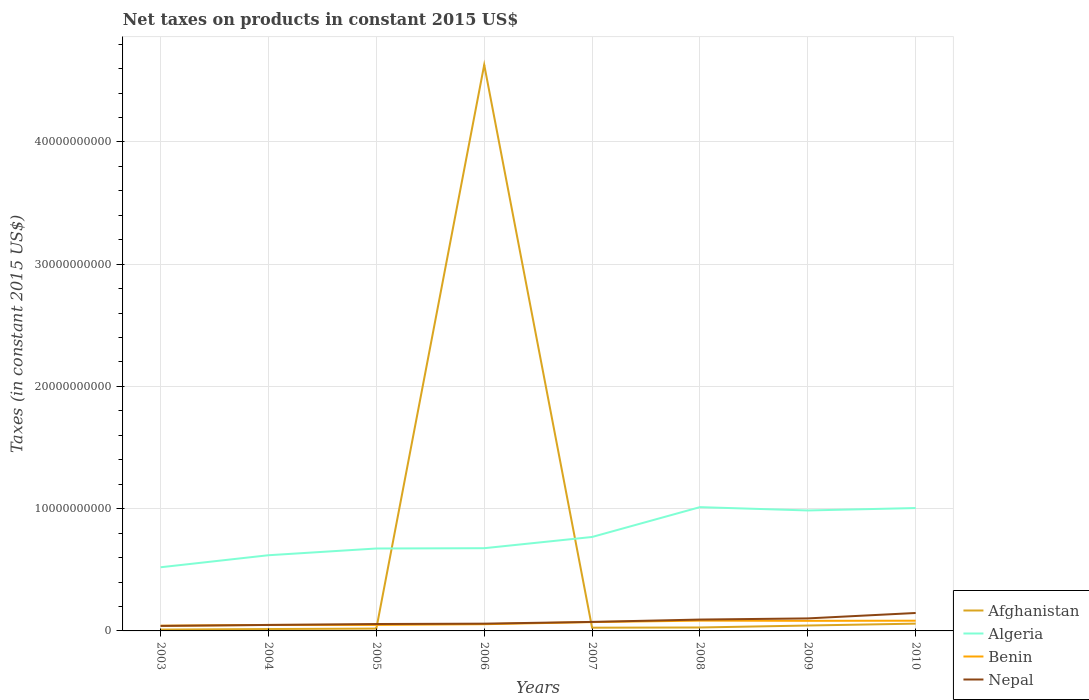Across all years, what is the maximum net taxes on products in Nepal?
Your answer should be very brief. 4.10e+08. In which year was the net taxes on products in Nepal maximum?
Provide a succinct answer. 2003. What is the total net taxes on products in Algeria in the graph?
Make the answer very short. -4.65e+09. What is the difference between the highest and the second highest net taxes on products in Algeria?
Make the answer very short. 4.92e+09. How many lines are there?
Your answer should be very brief. 4. What is the difference between two consecutive major ticks on the Y-axis?
Offer a very short reply. 1.00e+1. Where does the legend appear in the graph?
Keep it short and to the point. Bottom right. How are the legend labels stacked?
Make the answer very short. Vertical. What is the title of the graph?
Your response must be concise. Net taxes on products in constant 2015 US$. Does "Lesotho" appear as one of the legend labels in the graph?
Offer a very short reply. No. What is the label or title of the X-axis?
Offer a very short reply. Years. What is the label or title of the Y-axis?
Provide a succinct answer. Taxes (in constant 2015 US$). What is the Taxes (in constant 2015 US$) in Afghanistan in 2003?
Provide a succinct answer. 1.10e+08. What is the Taxes (in constant 2015 US$) in Algeria in 2003?
Keep it short and to the point. 5.21e+09. What is the Taxes (in constant 2015 US$) in Benin in 2003?
Your answer should be very brief. 4.25e+08. What is the Taxes (in constant 2015 US$) in Nepal in 2003?
Provide a succinct answer. 4.10e+08. What is the Taxes (in constant 2015 US$) in Afghanistan in 2004?
Your response must be concise. 1.54e+08. What is the Taxes (in constant 2015 US$) in Algeria in 2004?
Provide a short and direct response. 6.19e+09. What is the Taxes (in constant 2015 US$) in Benin in 2004?
Keep it short and to the point. 4.91e+08. What is the Taxes (in constant 2015 US$) of Nepal in 2004?
Provide a short and direct response. 4.89e+08. What is the Taxes (in constant 2015 US$) of Afghanistan in 2005?
Ensure brevity in your answer.  1.90e+08. What is the Taxes (in constant 2015 US$) in Algeria in 2005?
Provide a short and direct response. 6.74e+09. What is the Taxes (in constant 2015 US$) of Benin in 2005?
Provide a short and direct response. 4.91e+08. What is the Taxes (in constant 2015 US$) of Nepal in 2005?
Offer a very short reply. 5.65e+08. What is the Taxes (in constant 2015 US$) of Afghanistan in 2006?
Provide a succinct answer. 4.63e+1. What is the Taxes (in constant 2015 US$) of Algeria in 2006?
Your response must be concise. 6.77e+09. What is the Taxes (in constant 2015 US$) in Benin in 2006?
Ensure brevity in your answer.  5.49e+08. What is the Taxes (in constant 2015 US$) of Nepal in 2006?
Your response must be concise. 5.94e+08. What is the Taxes (in constant 2015 US$) of Afghanistan in 2007?
Make the answer very short. 2.65e+08. What is the Taxes (in constant 2015 US$) in Algeria in 2007?
Your answer should be very brief. 7.68e+09. What is the Taxes (in constant 2015 US$) of Benin in 2007?
Your response must be concise. 7.22e+08. What is the Taxes (in constant 2015 US$) of Nepal in 2007?
Offer a terse response. 7.37e+08. What is the Taxes (in constant 2015 US$) in Afghanistan in 2008?
Provide a succinct answer. 2.81e+08. What is the Taxes (in constant 2015 US$) in Algeria in 2008?
Your answer should be very brief. 1.01e+1. What is the Taxes (in constant 2015 US$) in Benin in 2008?
Your answer should be very brief. 8.43e+08. What is the Taxes (in constant 2015 US$) of Nepal in 2008?
Your response must be concise. 9.29e+08. What is the Taxes (in constant 2015 US$) of Afghanistan in 2009?
Ensure brevity in your answer.  4.42e+08. What is the Taxes (in constant 2015 US$) in Algeria in 2009?
Keep it short and to the point. 9.85e+09. What is the Taxes (in constant 2015 US$) in Benin in 2009?
Give a very brief answer. 8.26e+08. What is the Taxes (in constant 2015 US$) of Nepal in 2009?
Your response must be concise. 1.02e+09. What is the Taxes (in constant 2015 US$) of Afghanistan in 2010?
Give a very brief answer. 5.96e+08. What is the Taxes (in constant 2015 US$) of Algeria in 2010?
Your response must be concise. 1.01e+1. What is the Taxes (in constant 2015 US$) in Benin in 2010?
Provide a succinct answer. 8.35e+08. What is the Taxes (in constant 2015 US$) in Nepal in 2010?
Keep it short and to the point. 1.47e+09. Across all years, what is the maximum Taxes (in constant 2015 US$) in Afghanistan?
Provide a succinct answer. 4.63e+1. Across all years, what is the maximum Taxes (in constant 2015 US$) of Algeria?
Give a very brief answer. 1.01e+1. Across all years, what is the maximum Taxes (in constant 2015 US$) in Benin?
Make the answer very short. 8.43e+08. Across all years, what is the maximum Taxes (in constant 2015 US$) of Nepal?
Give a very brief answer. 1.47e+09. Across all years, what is the minimum Taxes (in constant 2015 US$) in Afghanistan?
Provide a succinct answer. 1.10e+08. Across all years, what is the minimum Taxes (in constant 2015 US$) in Algeria?
Your answer should be very brief. 5.21e+09. Across all years, what is the minimum Taxes (in constant 2015 US$) of Benin?
Provide a short and direct response. 4.25e+08. Across all years, what is the minimum Taxes (in constant 2015 US$) of Nepal?
Offer a terse response. 4.10e+08. What is the total Taxes (in constant 2015 US$) of Afghanistan in the graph?
Your answer should be very brief. 4.83e+1. What is the total Taxes (in constant 2015 US$) in Algeria in the graph?
Your response must be concise. 6.26e+1. What is the total Taxes (in constant 2015 US$) in Benin in the graph?
Give a very brief answer. 5.18e+09. What is the total Taxes (in constant 2015 US$) of Nepal in the graph?
Ensure brevity in your answer.  6.22e+09. What is the difference between the Taxes (in constant 2015 US$) of Afghanistan in 2003 and that in 2004?
Your answer should be very brief. -4.42e+07. What is the difference between the Taxes (in constant 2015 US$) of Algeria in 2003 and that in 2004?
Your answer should be compact. -9.83e+08. What is the difference between the Taxes (in constant 2015 US$) in Benin in 2003 and that in 2004?
Keep it short and to the point. -6.61e+07. What is the difference between the Taxes (in constant 2015 US$) of Nepal in 2003 and that in 2004?
Offer a terse response. -7.82e+07. What is the difference between the Taxes (in constant 2015 US$) in Afghanistan in 2003 and that in 2005?
Make the answer very short. -8.08e+07. What is the difference between the Taxes (in constant 2015 US$) of Algeria in 2003 and that in 2005?
Offer a terse response. -1.53e+09. What is the difference between the Taxes (in constant 2015 US$) of Benin in 2003 and that in 2005?
Ensure brevity in your answer.  -6.55e+07. What is the difference between the Taxes (in constant 2015 US$) in Nepal in 2003 and that in 2005?
Your answer should be very brief. -1.54e+08. What is the difference between the Taxes (in constant 2015 US$) in Afghanistan in 2003 and that in 2006?
Offer a terse response. -4.62e+1. What is the difference between the Taxes (in constant 2015 US$) in Algeria in 2003 and that in 2006?
Give a very brief answer. -1.56e+09. What is the difference between the Taxes (in constant 2015 US$) in Benin in 2003 and that in 2006?
Your response must be concise. -1.24e+08. What is the difference between the Taxes (in constant 2015 US$) in Nepal in 2003 and that in 2006?
Your answer should be compact. -1.84e+08. What is the difference between the Taxes (in constant 2015 US$) in Afghanistan in 2003 and that in 2007?
Give a very brief answer. -1.55e+08. What is the difference between the Taxes (in constant 2015 US$) of Algeria in 2003 and that in 2007?
Your response must be concise. -2.48e+09. What is the difference between the Taxes (in constant 2015 US$) in Benin in 2003 and that in 2007?
Provide a short and direct response. -2.97e+08. What is the difference between the Taxes (in constant 2015 US$) in Nepal in 2003 and that in 2007?
Make the answer very short. -3.27e+08. What is the difference between the Taxes (in constant 2015 US$) in Afghanistan in 2003 and that in 2008?
Offer a terse response. -1.72e+08. What is the difference between the Taxes (in constant 2015 US$) of Algeria in 2003 and that in 2008?
Your answer should be very brief. -4.92e+09. What is the difference between the Taxes (in constant 2015 US$) of Benin in 2003 and that in 2008?
Provide a succinct answer. -4.18e+08. What is the difference between the Taxes (in constant 2015 US$) of Nepal in 2003 and that in 2008?
Your answer should be compact. -5.19e+08. What is the difference between the Taxes (in constant 2015 US$) of Afghanistan in 2003 and that in 2009?
Make the answer very short. -3.33e+08. What is the difference between the Taxes (in constant 2015 US$) in Algeria in 2003 and that in 2009?
Give a very brief answer. -4.65e+09. What is the difference between the Taxes (in constant 2015 US$) in Benin in 2003 and that in 2009?
Keep it short and to the point. -4.01e+08. What is the difference between the Taxes (in constant 2015 US$) in Nepal in 2003 and that in 2009?
Your answer should be very brief. -6.14e+08. What is the difference between the Taxes (in constant 2015 US$) in Afghanistan in 2003 and that in 2010?
Provide a short and direct response. -4.87e+08. What is the difference between the Taxes (in constant 2015 US$) of Algeria in 2003 and that in 2010?
Keep it short and to the point. -4.84e+09. What is the difference between the Taxes (in constant 2015 US$) in Benin in 2003 and that in 2010?
Provide a short and direct response. -4.10e+08. What is the difference between the Taxes (in constant 2015 US$) in Nepal in 2003 and that in 2010?
Provide a short and direct response. -1.06e+09. What is the difference between the Taxes (in constant 2015 US$) of Afghanistan in 2004 and that in 2005?
Provide a short and direct response. -3.66e+07. What is the difference between the Taxes (in constant 2015 US$) of Algeria in 2004 and that in 2005?
Give a very brief answer. -5.51e+08. What is the difference between the Taxes (in constant 2015 US$) in Benin in 2004 and that in 2005?
Give a very brief answer. 5.67e+05. What is the difference between the Taxes (in constant 2015 US$) of Nepal in 2004 and that in 2005?
Keep it short and to the point. -7.60e+07. What is the difference between the Taxes (in constant 2015 US$) in Afghanistan in 2004 and that in 2006?
Your answer should be compact. -4.62e+1. What is the difference between the Taxes (in constant 2015 US$) in Algeria in 2004 and that in 2006?
Make the answer very short. -5.75e+08. What is the difference between the Taxes (in constant 2015 US$) of Benin in 2004 and that in 2006?
Give a very brief answer. -5.82e+07. What is the difference between the Taxes (in constant 2015 US$) in Nepal in 2004 and that in 2006?
Ensure brevity in your answer.  -1.06e+08. What is the difference between the Taxes (in constant 2015 US$) in Afghanistan in 2004 and that in 2007?
Keep it short and to the point. -1.11e+08. What is the difference between the Taxes (in constant 2015 US$) of Algeria in 2004 and that in 2007?
Your response must be concise. -1.49e+09. What is the difference between the Taxes (in constant 2015 US$) of Benin in 2004 and that in 2007?
Your answer should be compact. -2.31e+08. What is the difference between the Taxes (in constant 2015 US$) in Nepal in 2004 and that in 2007?
Make the answer very short. -2.49e+08. What is the difference between the Taxes (in constant 2015 US$) in Afghanistan in 2004 and that in 2008?
Your answer should be compact. -1.28e+08. What is the difference between the Taxes (in constant 2015 US$) of Algeria in 2004 and that in 2008?
Your answer should be compact. -3.93e+09. What is the difference between the Taxes (in constant 2015 US$) of Benin in 2004 and that in 2008?
Your answer should be compact. -3.52e+08. What is the difference between the Taxes (in constant 2015 US$) in Nepal in 2004 and that in 2008?
Provide a succinct answer. -4.40e+08. What is the difference between the Taxes (in constant 2015 US$) in Afghanistan in 2004 and that in 2009?
Give a very brief answer. -2.88e+08. What is the difference between the Taxes (in constant 2015 US$) of Algeria in 2004 and that in 2009?
Offer a very short reply. -3.66e+09. What is the difference between the Taxes (in constant 2015 US$) of Benin in 2004 and that in 2009?
Your response must be concise. -3.35e+08. What is the difference between the Taxes (in constant 2015 US$) of Nepal in 2004 and that in 2009?
Keep it short and to the point. -5.36e+08. What is the difference between the Taxes (in constant 2015 US$) in Afghanistan in 2004 and that in 2010?
Provide a short and direct response. -4.42e+08. What is the difference between the Taxes (in constant 2015 US$) in Algeria in 2004 and that in 2010?
Provide a succinct answer. -3.86e+09. What is the difference between the Taxes (in constant 2015 US$) in Benin in 2004 and that in 2010?
Offer a very short reply. -3.44e+08. What is the difference between the Taxes (in constant 2015 US$) in Nepal in 2004 and that in 2010?
Your answer should be very brief. -9.79e+08. What is the difference between the Taxes (in constant 2015 US$) in Afghanistan in 2005 and that in 2006?
Provide a short and direct response. -4.61e+1. What is the difference between the Taxes (in constant 2015 US$) of Algeria in 2005 and that in 2006?
Provide a short and direct response. -2.43e+07. What is the difference between the Taxes (in constant 2015 US$) in Benin in 2005 and that in 2006?
Provide a short and direct response. -5.88e+07. What is the difference between the Taxes (in constant 2015 US$) of Nepal in 2005 and that in 2006?
Your response must be concise. -2.95e+07. What is the difference between the Taxes (in constant 2015 US$) in Afghanistan in 2005 and that in 2007?
Make the answer very short. -7.45e+07. What is the difference between the Taxes (in constant 2015 US$) of Algeria in 2005 and that in 2007?
Offer a terse response. -9.42e+08. What is the difference between the Taxes (in constant 2015 US$) of Benin in 2005 and that in 2007?
Ensure brevity in your answer.  -2.31e+08. What is the difference between the Taxes (in constant 2015 US$) in Nepal in 2005 and that in 2007?
Your answer should be compact. -1.73e+08. What is the difference between the Taxes (in constant 2015 US$) of Afghanistan in 2005 and that in 2008?
Give a very brief answer. -9.09e+07. What is the difference between the Taxes (in constant 2015 US$) of Algeria in 2005 and that in 2008?
Your response must be concise. -3.38e+09. What is the difference between the Taxes (in constant 2015 US$) in Benin in 2005 and that in 2008?
Your answer should be very brief. -3.52e+08. What is the difference between the Taxes (in constant 2015 US$) in Nepal in 2005 and that in 2008?
Offer a terse response. -3.64e+08. What is the difference between the Taxes (in constant 2015 US$) of Afghanistan in 2005 and that in 2009?
Provide a succinct answer. -2.52e+08. What is the difference between the Taxes (in constant 2015 US$) in Algeria in 2005 and that in 2009?
Offer a very short reply. -3.11e+09. What is the difference between the Taxes (in constant 2015 US$) of Benin in 2005 and that in 2009?
Provide a succinct answer. -3.35e+08. What is the difference between the Taxes (in constant 2015 US$) of Nepal in 2005 and that in 2009?
Give a very brief answer. -4.60e+08. What is the difference between the Taxes (in constant 2015 US$) in Afghanistan in 2005 and that in 2010?
Offer a terse response. -4.06e+08. What is the difference between the Taxes (in constant 2015 US$) of Algeria in 2005 and that in 2010?
Give a very brief answer. -3.31e+09. What is the difference between the Taxes (in constant 2015 US$) in Benin in 2005 and that in 2010?
Provide a short and direct response. -3.45e+08. What is the difference between the Taxes (in constant 2015 US$) in Nepal in 2005 and that in 2010?
Your response must be concise. -9.03e+08. What is the difference between the Taxes (in constant 2015 US$) of Afghanistan in 2006 and that in 2007?
Give a very brief answer. 4.60e+1. What is the difference between the Taxes (in constant 2015 US$) in Algeria in 2006 and that in 2007?
Offer a very short reply. -9.18e+08. What is the difference between the Taxes (in constant 2015 US$) in Benin in 2006 and that in 2007?
Offer a very short reply. -1.73e+08. What is the difference between the Taxes (in constant 2015 US$) in Nepal in 2006 and that in 2007?
Offer a terse response. -1.43e+08. What is the difference between the Taxes (in constant 2015 US$) in Afghanistan in 2006 and that in 2008?
Offer a terse response. 4.60e+1. What is the difference between the Taxes (in constant 2015 US$) of Algeria in 2006 and that in 2008?
Keep it short and to the point. -3.36e+09. What is the difference between the Taxes (in constant 2015 US$) in Benin in 2006 and that in 2008?
Ensure brevity in your answer.  -2.93e+08. What is the difference between the Taxes (in constant 2015 US$) in Nepal in 2006 and that in 2008?
Keep it short and to the point. -3.35e+08. What is the difference between the Taxes (in constant 2015 US$) of Afghanistan in 2006 and that in 2009?
Offer a very short reply. 4.59e+1. What is the difference between the Taxes (in constant 2015 US$) in Algeria in 2006 and that in 2009?
Your response must be concise. -3.09e+09. What is the difference between the Taxes (in constant 2015 US$) of Benin in 2006 and that in 2009?
Give a very brief answer. -2.76e+08. What is the difference between the Taxes (in constant 2015 US$) of Nepal in 2006 and that in 2009?
Your answer should be very brief. -4.30e+08. What is the difference between the Taxes (in constant 2015 US$) in Afghanistan in 2006 and that in 2010?
Ensure brevity in your answer.  4.57e+1. What is the difference between the Taxes (in constant 2015 US$) in Algeria in 2006 and that in 2010?
Make the answer very short. -3.29e+09. What is the difference between the Taxes (in constant 2015 US$) of Benin in 2006 and that in 2010?
Give a very brief answer. -2.86e+08. What is the difference between the Taxes (in constant 2015 US$) in Nepal in 2006 and that in 2010?
Give a very brief answer. -8.73e+08. What is the difference between the Taxes (in constant 2015 US$) of Afghanistan in 2007 and that in 2008?
Give a very brief answer. -1.64e+07. What is the difference between the Taxes (in constant 2015 US$) of Algeria in 2007 and that in 2008?
Provide a succinct answer. -2.44e+09. What is the difference between the Taxes (in constant 2015 US$) of Benin in 2007 and that in 2008?
Provide a short and direct response. -1.21e+08. What is the difference between the Taxes (in constant 2015 US$) in Nepal in 2007 and that in 2008?
Make the answer very short. -1.92e+08. What is the difference between the Taxes (in constant 2015 US$) in Afghanistan in 2007 and that in 2009?
Your answer should be compact. -1.77e+08. What is the difference between the Taxes (in constant 2015 US$) of Algeria in 2007 and that in 2009?
Your answer should be compact. -2.17e+09. What is the difference between the Taxes (in constant 2015 US$) in Benin in 2007 and that in 2009?
Provide a short and direct response. -1.04e+08. What is the difference between the Taxes (in constant 2015 US$) of Nepal in 2007 and that in 2009?
Offer a very short reply. -2.87e+08. What is the difference between the Taxes (in constant 2015 US$) in Afghanistan in 2007 and that in 2010?
Ensure brevity in your answer.  -3.31e+08. What is the difference between the Taxes (in constant 2015 US$) of Algeria in 2007 and that in 2010?
Ensure brevity in your answer.  -2.37e+09. What is the difference between the Taxes (in constant 2015 US$) in Benin in 2007 and that in 2010?
Your response must be concise. -1.13e+08. What is the difference between the Taxes (in constant 2015 US$) in Nepal in 2007 and that in 2010?
Offer a terse response. -7.30e+08. What is the difference between the Taxes (in constant 2015 US$) of Afghanistan in 2008 and that in 2009?
Your answer should be very brief. -1.61e+08. What is the difference between the Taxes (in constant 2015 US$) in Algeria in 2008 and that in 2009?
Ensure brevity in your answer.  2.72e+08. What is the difference between the Taxes (in constant 2015 US$) of Benin in 2008 and that in 2009?
Ensure brevity in your answer.  1.70e+07. What is the difference between the Taxes (in constant 2015 US$) of Nepal in 2008 and that in 2009?
Offer a very short reply. -9.53e+07. What is the difference between the Taxes (in constant 2015 US$) in Afghanistan in 2008 and that in 2010?
Provide a short and direct response. -3.15e+08. What is the difference between the Taxes (in constant 2015 US$) in Algeria in 2008 and that in 2010?
Your answer should be compact. 7.40e+07. What is the difference between the Taxes (in constant 2015 US$) of Benin in 2008 and that in 2010?
Offer a very short reply. 7.49e+06. What is the difference between the Taxes (in constant 2015 US$) of Nepal in 2008 and that in 2010?
Give a very brief answer. -5.38e+08. What is the difference between the Taxes (in constant 2015 US$) of Afghanistan in 2009 and that in 2010?
Offer a very short reply. -1.54e+08. What is the difference between the Taxes (in constant 2015 US$) of Algeria in 2009 and that in 2010?
Offer a very short reply. -1.98e+08. What is the difference between the Taxes (in constant 2015 US$) of Benin in 2009 and that in 2010?
Offer a terse response. -9.56e+06. What is the difference between the Taxes (in constant 2015 US$) in Nepal in 2009 and that in 2010?
Your answer should be compact. -4.43e+08. What is the difference between the Taxes (in constant 2015 US$) of Afghanistan in 2003 and the Taxes (in constant 2015 US$) of Algeria in 2004?
Keep it short and to the point. -6.08e+09. What is the difference between the Taxes (in constant 2015 US$) in Afghanistan in 2003 and the Taxes (in constant 2015 US$) in Benin in 2004?
Make the answer very short. -3.82e+08. What is the difference between the Taxes (in constant 2015 US$) of Afghanistan in 2003 and the Taxes (in constant 2015 US$) of Nepal in 2004?
Provide a short and direct response. -3.79e+08. What is the difference between the Taxes (in constant 2015 US$) in Algeria in 2003 and the Taxes (in constant 2015 US$) in Benin in 2004?
Offer a very short reply. 4.72e+09. What is the difference between the Taxes (in constant 2015 US$) in Algeria in 2003 and the Taxes (in constant 2015 US$) in Nepal in 2004?
Give a very brief answer. 4.72e+09. What is the difference between the Taxes (in constant 2015 US$) of Benin in 2003 and the Taxes (in constant 2015 US$) of Nepal in 2004?
Offer a very short reply. -6.34e+07. What is the difference between the Taxes (in constant 2015 US$) in Afghanistan in 2003 and the Taxes (in constant 2015 US$) in Algeria in 2005?
Offer a terse response. -6.63e+09. What is the difference between the Taxes (in constant 2015 US$) of Afghanistan in 2003 and the Taxes (in constant 2015 US$) of Benin in 2005?
Offer a terse response. -3.81e+08. What is the difference between the Taxes (in constant 2015 US$) in Afghanistan in 2003 and the Taxes (in constant 2015 US$) in Nepal in 2005?
Keep it short and to the point. -4.55e+08. What is the difference between the Taxes (in constant 2015 US$) in Algeria in 2003 and the Taxes (in constant 2015 US$) in Benin in 2005?
Keep it short and to the point. 4.72e+09. What is the difference between the Taxes (in constant 2015 US$) in Algeria in 2003 and the Taxes (in constant 2015 US$) in Nepal in 2005?
Offer a terse response. 4.64e+09. What is the difference between the Taxes (in constant 2015 US$) in Benin in 2003 and the Taxes (in constant 2015 US$) in Nepal in 2005?
Keep it short and to the point. -1.39e+08. What is the difference between the Taxes (in constant 2015 US$) of Afghanistan in 2003 and the Taxes (in constant 2015 US$) of Algeria in 2006?
Your answer should be very brief. -6.66e+09. What is the difference between the Taxes (in constant 2015 US$) in Afghanistan in 2003 and the Taxes (in constant 2015 US$) in Benin in 2006?
Offer a very short reply. -4.40e+08. What is the difference between the Taxes (in constant 2015 US$) in Afghanistan in 2003 and the Taxes (in constant 2015 US$) in Nepal in 2006?
Offer a very short reply. -4.85e+08. What is the difference between the Taxes (in constant 2015 US$) in Algeria in 2003 and the Taxes (in constant 2015 US$) in Benin in 2006?
Keep it short and to the point. 4.66e+09. What is the difference between the Taxes (in constant 2015 US$) of Algeria in 2003 and the Taxes (in constant 2015 US$) of Nepal in 2006?
Your response must be concise. 4.61e+09. What is the difference between the Taxes (in constant 2015 US$) of Benin in 2003 and the Taxes (in constant 2015 US$) of Nepal in 2006?
Your answer should be compact. -1.69e+08. What is the difference between the Taxes (in constant 2015 US$) of Afghanistan in 2003 and the Taxes (in constant 2015 US$) of Algeria in 2007?
Offer a very short reply. -7.57e+09. What is the difference between the Taxes (in constant 2015 US$) in Afghanistan in 2003 and the Taxes (in constant 2015 US$) in Benin in 2007?
Ensure brevity in your answer.  -6.13e+08. What is the difference between the Taxes (in constant 2015 US$) of Afghanistan in 2003 and the Taxes (in constant 2015 US$) of Nepal in 2007?
Ensure brevity in your answer.  -6.28e+08. What is the difference between the Taxes (in constant 2015 US$) in Algeria in 2003 and the Taxes (in constant 2015 US$) in Benin in 2007?
Provide a succinct answer. 4.49e+09. What is the difference between the Taxes (in constant 2015 US$) in Algeria in 2003 and the Taxes (in constant 2015 US$) in Nepal in 2007?
Your answer should be compact. 4.47e+09. What is the difference between the Taxes (in constant 2015 US$) in Benin in 2003 and the Taxes (in constant 2015 US$) in Nepal in 2007?
Give a very brief answer. -3.12e+08. What is the difference between the Taxes (in constant 2015 US$) of Afghanistan in 2003 and the Taxes (in constant 2015 US$) of Algeria in 2008?
Offer a very short reply. -1.00e+1. What is the difference between the Taxes (in constant 2015 US$) in Afghanistan in 2003 and the Taxes (in constant 2015 US$) in Benin in 2008?
Offer a very short reply. -7.33e+08. What is the difference between the Taxes (in constant 2015 US$) in Afghanistan in 2003 and the Taxes (in constant 2015 US$) in Nepal in 2008?
Offer a very short reply. -8.19e+08. What is the difference between the Taxes (in constant 2015 US$) in Algeria in 2003 and the Taxes (in constant 2015 US$) in Benin in 2008?
Offer a terse response. 4.37e+09. What is the difference between the Taxes (in constant 2015 US$) of Algeria in 2003 and the Taxes (in constant 2015 US$) of Nepal in 2008?
Keep it short and to the point. 4.28e+09. What is the difference between the Taxes (in constant 2015 US$) in Benin in 2003 and the Taxes (in constant 2015 US$) in Nepal in 2008?
Provide a succinct answer. -5.04e+08. What is the difference between the Taxes (in constant 2015 US$) of Afghanistan in 2003 and the Taxes (in constant 2015 US$) of Algeria in 2009?
Ensure brevity in your answer.  -9.74e+09. What is the difference between the Taxes (in constant 2015 US$) in Afghanistan in 2003 and the Taxes (in constant 2015 US$) in Benin in 2009?
Provide a short and direct response. -7.16e+08. What is the difference between the Taxes (in constant 2015 US$) of Afghanistan in 2003 and the Taxes (in constant 2015 US$) of Nepal in 2009?
Your answer should be compact. -9.15e+08. What is the difference between the Taxes (in constant 2015 US$) of Algeria in 2003 and the Taxes (in constant 2015 US$) of Benin in 2009?
Your answer should be compact. 4.38e+09. What is the difference between the Taxes (in constant 2015 US$) of Algeria in 2003 and the Taxes (in constant 2015 US$) of Nepal in 2009?
Provide a short and direct response. 4.18e+09. What is the difference between the Taxes (in constant 2015 US$) of Benin in 2003 and the Taxes (in constant 2015 US$) of Nepal in 2009?
Offer a very short reply. -5.99e+08. What is the difference between the Taxes (in constant 2015 US$) in Afghanistan in 2003 and the Taxes (in constant 2015 US$) in Algeria in 2010?
Offer a very short reply. -9.94e+09. What is the difference between the Taxes (in constant 2015 US$) of Afghanistan in 2003 and the Taxes (in constant 2015 US$) of Benin in 2010?
Your response must be concise. -7.26e+08. What is the difference between the Taxes (in constant 2015 US$) in Afghanistan in 2003 and the Taxes (in constant 2015 US$) in Nepal in 2010?
Ensure brevity in your answer.  -1.36e+09. What is the difference between the Taxes (in constant 2015 US$) in Algeria in 2003 and the Taxes (in constant 2015 US$) in Benin in 2010?
Provide a short and direct response. 4.37e+09. What is the difference between the Taxes (in constant 2015 US$) in Algeria in 2003 and the Taxes (in constant 2015 US$) in Nepal in 2010?
Provide a succinct answer. 3.74e+09. What is the difference between the Taxes (in constant 2015 US$) of Benin in 2003 and the Taxes (in constant 2015 US$) of Nepal in 2010?
Offer a terse response. -1.04e+09. What is the difference between the Taxes (in constant 2015 US$) of Afghanistan in 2004 and the Taxes (in constant 2015 US$) of Algeria in 2005?
Keep it short and to the point. -6.59e+09. What is the difference between the Taxes (in constant 2015 US$) in Afghanistan in 2004 and the Taxes (in constant 2015 US$) in Benin in 2005?
Offer a terse response. -3.37e+08. What is the difference between the Taxes (in constant 2015 US$) of Afghanistan in 2004 and the Taxes (in constant 2015 US$) of Nepal in 2005?
Provide a short and direct response. -4.11e+08. What is the difference between the Taxes (in constant 2015 US$) of Algeria in 2004 and the Taxes (in constant 2015 US$) of Benin in 2005?
Provide a short and direct response. 5.70e+09. What is the difference between the Taxes (in constant 2015 US$) in Algeria in 2004 and the Taxes (in constant 2015 US$) in Nepal in 2005?
Your answer should be very brief. 5.63e+09. What is the difference between the Taxes (in constant 2015 US$) of Benin in 2004 and the Taxes (in constant 2015 US$) of Nepal in 2005?
Offer a terse response. -7.33e+07. What is the difference between the Taxes (in constant 2015 US$) of Afghanistan in 2004 and the Taxes (in constant 2015 US$) of Algeria in 2006?
Provide a short and direct response. -6.61e+09. What is the difference between the Taxes (in constant 2015 US$) of Afghanistan in 2004 and the Taxes (in constant 2015 US$) of Benin in 2006?
Offer a terse response. -3.96e+08. What is the difference between the Taxes (in constant 2015 US$) of Afghanistan in 2004 and the Taxes (in constant 2015 US$) of Nepal in 2006?
Your answer should be very brief. -4.40e+08. What is the difference between the Taxes (in constant 2015 US$) of Algeria in 2004 and the Taxes (in constant 2015 US$) of Benin in 2006?
Offer a terse response. 5.64e+09. What is the difference between the Taxes (in constant 2015 US$) of Algeria in 2004 and the Taxes (in constant 2015 US$) of Nepal in 2006?
Offer a very short reply. 5.60e+09. What is the difference between the Taxes (in constant 2015 US$) in Benin in 2004 and the Taxes (in constant 2015 US$) in Nepal in 2006?
Offer a very short reply. -1.03e+08. What is the difference between the Taxes (in constant 2015 US$) in Afghanistan in 2004 and the Taxes (in constant 2015 US$) in Algeria in 2007?
Your answer should be compact. -7.53e+09. What is the difference between the Taxes (in constant 2015 US$) in Afghanistan in 2004 and the Taxes (in constant 2015 US$) in Benin in 2007?
Your answer should be very brief. -5.68e+08. What is the difference between the Taxes (in constant 2015 US$) of Afghanistan in 2004 and the Taxes (in constant 2015 US$) of Nepal in 2007?
Offer a very short reply. -5.84e+08. What is the difference between the Taxes (in constant 2015 US$) of Algeria in 2004 and the Taxes (in constant 2015 US$) of Benin in 2007?
Provide a short and direct response. 5.47e+09. What is the difference between the Taxes (in constant 2015 US$) in Algeria in 2004 and the Taxes (in constant 2015 US$) in Nepal in 2007?
Offer a terse response. 5.45e+09. What is the difference between the Taxes (in constant 2015 US$) of Benin in 2004 and the Taxes (in constant 2015 US$) of Nepal in 2007?
Provide a succinct answer. -2.46e+08. What is the difference between the Taxes (in constant 2015 US$) of Afghanistan in 2004 and the Taxes (in constant 2015 US$) of Algeria in 2008?
Your answer should be very brief. -9.97e+09. What is the difference between the Taxes (in constant 2015 US$) in Afghanistan in 2004 and the Taxes (in constant 2015 US$) in Benin in 2008?
Make the answer very short. -6.89e+08. What is the difference between the Taxes (in constant 2015 US$) in Afghanistan in 2004 and the Taxes (in constant 2015 US$) in Nepal in 2008?
Give a very brief answer. -7.75e+08. What is the difference between the Taxes (in constant 2015 US$) in Algeria in 2004 and the Taxes (in constant 2015 US$) in Benin in 2008?
Keep it short and to the point. 5.35e+09. What is the difference between the Taxes (in constant 2015 US$) of Algeria in 2004 and the Taxes (in constant 2015 US$) of Nepal in 2008?
Your response must be concise. 5.26e+09. What is the difference between the Taxes (in constant 2015 US$) in Benin in 2004 and the Taxes (in constant 2015 US$) in Nepal in 2008?
Provide a short and direct response. -4.38e+08. What is the difference between the Taxes (in constant 2015 US$) in Afghanistan in 2004 and the Taxes (in constant 2015 US$) in Algeria in 2009?
Your answer should be compact. -9.70e+09. What is the difference between the Taxes (in constant 2015 US$) in Afghanistan in 2004 and the Taxes (in constant 2015 US$) in Benin in 2009?
Give a very brief answer. -6.72e+08. What is the difference between the Taxes (in constant 2015 US$) of Afghanistan in 2004 and the Taxes (in constant 2015 US$) of Nepal in 2009?
Offer a very short reply. -8.71e+08. What is the difference between the Taxes (in constant 2015 US$) of Algeria in 2004 and the Taxes (in constant 2015 US$) of Benin in 2009?
Provide a succinct answer. 5.37e+09. What is the difference between the Taxes (in constant 2015 US$) in Algeria in 2004 and the Taxes (in constant 2015 US$) in Nepal in 2009?
Provide a short and direct response. 5.17e+09. What is the difference between the Taxes (in constant 2015 US$) of Benin in 2004 and the Taxes (in constant 2015 US$) of Nepal in 2009?
Offer a very short reply. -5.33e+08. What is the difference between the Taxes (in constant 2015 US$) in Afghanistan in 2004 and the Taxes (in constant 2015 US$) in Algeria in 2010?
Offer a terse response. -9.90e+09. What is the difference between the Taxes (in constant 2015 US$) of Afghanistan in 2004 and the Taxes (in constant 2015 US$) of Benin in 2010?
Ensure brevity in your answer.  -6.82e+08. What is the difference between the Taxes (in constant 2015 US$) in Afghanistan in 2004 and the Taxes (in constant 2015 US$) in Nepal in 2010?
Offer a very short reply. -1.31e+09. What is the difference between the Taxes (in constant 2015 US$) of Algeria in 2004 and the Taxes (in constant 2015 US$) of Benin in 2010?
Make the answer very short. 5.36e+09. What is the difference between the Taxes (in constant 2015 US$) of Algeria in 2004 and the Taxes (in constant 2015 US$) of Nepal in 2010?
Your response must be concise. 4.72e+09. What is the difference between the Taxes (in constant 2015 US$) in Benin in 2004 and the Taxes (in constant 2015 US$) in Nepal in 2010?
Give a very brief answer. -9.76e+08. What is the difference between the Taxes (in constant 2015 US$) in Afghanistan in 2005 and the Taxes (in constant 2015 US$) in Algeria in 2006?
Keep it short and to the point. -6.58e+09. What is the difference between the Taxes (in constant 2015 US$) in Afghanistan in 2005 and the Taxes (in constant 2015 US$) in Benin in 2006?
Provide a short and direct response. -3.59e+08. What is the difference between the Taxes (in constant 2015 US$) of Afghanistan in 2005 and the Taxes (in constant 2015 US$) of Nepal in 2006?
Ensure brevity in your answer.  -4.04e+08. What is the difference between the Taxes (in constant 2015 US$) in Algeria in 2005 and the Taxes (in constant 2015 US$) in Benin in 2006?
Your answer should be compact. 6.19e+09. What is the difference between the Taxes (in constant 2015 US$) of Algeria in 2005 and the Taxes (in constant 2015 US$) of Nepal in 2006?
Give a very brief answer. 6.15e+09. What is the difference between the Taxes (in constant 2015 US$) of Benin in 2005 and the Taxes (in constant 2015 US$) of Nepal in 2006?
Provide a succinct answer. -1.03e+08. What is the difference between the Taxes (in constant 2015 US$) in Afghanistan in 2005 and the Taxes (in constant 2015 US$) in Algeria in 2007?
Give a very brief answer. -7.49e+09. What is the difference between the Taxes (in constant 2015 US$) of Afghanistan in 2005 and the Taxes (in constant 2015 US$) of Benin in 2007?
Your answer should be compact. -5.32e+08. What is the difference between the Taxes (in constant 2015 US$) in Afghanistan in 2005 and the Taxes (in constant 2015 US$) in Nepal in 2007?
Ensure brevity in your answer.  -5.47e+08. What is the difference between the Taxes (in constant 2015 US$) in Algeria in 2005 and the Taxes (in constant 2015 US$) in Benin in 2007?
Your answer should be compact. 6.02e+09. What is the difference between the Taxes (in constant 2015 US$) in Algeria in 2005 and the Taxes (in constant 2015 US$) in Nepal in 2007?
Provide a succinct answer. 6.00e+09. What is the difference between the Taxes (in constant 2015 US$) of Benin in 2005 and the Taxes (in constant 2015 US$) of Nepal in 2007?
Keep it short and to the point. -2.47e+08. What is the difference between the Taxes (in constant 2015 US$) of Afghanistan in 2005 and the Taxes (in constant 2015 US$) of Algeria in 2008?
Your answer should be compact. -9.94e+09. What is the difference between the Taxes (in constant 2015 US$) in Afghanistan in 2005 and the Taxes (in constant 2015 US$) in Benin in 2008?
Your answer should be very brief. -6.52e+08. What is the difference between the Taxes (in constant 2015 US$) of Afghanistan in 2005 and the Taxes (in constant 2015 US$) of Nepal in 2008?
Provide a short and direct response. -7.39e+08. What is the difference between the Taxes (in constant 2015 US$) in Algeria in 2005 and the Taxes (in constant 2015 US$) in Benin in 2008?
Keep it short and to the point. 5.90e+09. What is the difference between the Taxes (in constant 2015 US$) in Algeria in 2005 and the Taxes (in constant 2015 US$) in Nepal in 2008?
Offer a very short reply. 5.81e+09. What is the difference between the Taxes (in constant 2015 US$) of Benin in 2005 and the Taxes (in constant 2015 US$) of Nepal in 2008?
Offer a very short reply. -4.38e+08. What is the difference between the Taxes (in constant 2015 US$) in Afghanistan in 2005 and the Taxes (in constant 2015 US$) in Algeria in 2009?
Offer a terse response. -9.66e+09. What is the difference between the Taxes (in constant 2015 US$) of Afghanistan in 2005 and the Taxes (in constant 2015 US$) of Benin in 2009?
Offer a terse response. -6.35e+08. What is the difference between the Taxes (in constant 2015 US$) in Afghanistan in 2005 and the Taxes (in constant 2015 US$) in Nepal in 2009?
Offer a very short reply. -8.34e+08. What is the difference between the Taxes (in constant 2015 US$) of Algeria in 2005 and the Taxes (in constant 2015 US$) of Benin in 2009?
Offer a very short reply. 5.92e+09. What is the difference between the Taxes (in constant 2015 US$) in Algeria in 2005 and the Taxes (in constant 2015 US$) in Nepal in 2009?
Offer a very short reply. 5.72e+09. What is the difference between the Taxes (in constant 2015 US$) in Benin in 2005 and the Taxes (in constant 2015 US$) in Nepal in 2009?
Keep it short and to the point. -5.34e+08. What is the difference between the Taxes (in constant 2015 US$) of Afghanistan in 2005 and the Taxes (in constant 2015 US$) of Algeria in 2010?
Keep it short and to the point. -9.86e+09. What is the difference between the Taxes (in constant 2015 US$) in Afghanistan in 2005 and the Taxes (in constant 2015 US$) in Benin in 2010?
Offer a terse response. -6.45e+08. What is the difference between the Taxes (in constant 2015 US$) in Afghanistan in 2005 and the Taxes (in constant 2015 US$) in Nepal in 2010?
Your response must be concise. -1.28e+09. What is the difference between the Taxes (in constant 2015 US$) in Algeria in 2005 and the Taxes (in constant 2015 US$) in Benin in 2010?
Your answer should be very brief. 5.91e+09. What is the difference between the Taxes (in constant 2015 US$) of Algeria in 2005 and the Taxes (in constant 2015 US$) of Nepal in 2010?
Your answer should be compact. 5.27e+09. What is the difference between the Taxes (in constant 2015 US$) in Benin in 2005 and the Taxes (in constant 2015 US$) in Nepal in 2010?
Make the answer very short. -9.77e+08. What is the difference between the Taxes (in constant 2015 US$) of Afghanistan in 2006 and the Taxes (in constant 2015 US$) of Algeria in 2007?
Offer a terse response. 3.86e+1. What is the difference between the Taxes (in constant 2015 US$) in Afghanistan in 2006 and the Taxes (in constant 2015 US$) in Benin in 2007?
Ensure brevity in your answer.  4.56e+1. What is the difference between the Taxes (in constant 2015 US$) in Afghanistan in 2006 and the Taxes (in constant 2015 US$) in Nepal in 2007?
Offer a very short reply. 4.56e+1. What is the difference between the Taxes (in constant 2015 US$) of Algeria in 2006 and the Taxes (in constant 2015 US$) of Benin in 2007?
Your answer should be compact. 6.04e+09. What is the difference between the Taxes (in constant 2015 US$) in Algeria in 2006 and the Taxes (in constant 2015 US$) in Nepal in 2007?
Offer a very short reply. 6.03e+09. What is the difference between the Taxes (in constant 2015 US$) in Benin in 2006 and the Taxes (in constant 2015 US$) in Nepal in 2007?
Keep it short and to the point. -1.88e+08. What is the difference between the Taxes (in constant 2015 US$) of Afghanistan in 2006 and the Taxes (in constant 2015 US$) of Algeria in 2008?
Your answer should be compact. 3.62e+1. What is the difference between the Taxes (in constant 2015 US$) of Afghanistan in 2006 and the Taxes (in constant 2015 US$) of Benin in 2008?
Give a very brief answer. 4.55e+1. What is the difference between the Taxes (in constant 2015 US$) in Afghanistan in 2006 and the Taxes (in constant 2015 US$) in Nepal in 2008?
Provide a succinct answer. 4.54e+1. What is the difference between the Taxes (in constant 2015 US$) of Algeria in 2006 and the Taxes (in constant 2015 US$) of Benin in 2008?
Your answer should be very brief. 5.92e+09. What is the difference between the Taxes (in constant 2015 US$) of Algeria in 2006 and the Taxes (in constant 2015 US$) of Nepal in 2008?
Give a very brief answer. 5.84e+09. What is the difference between the Taxes (in constant 2015 US$) of Benin in 2006 and the Taxes (in constant 2015 US$) of Nepal in 2008?
Keep it short and to the point. -3.80e+08. What is the difference between the Taxes (in constant 2015 US$) of Afghanistan in 2006 and the Taxes (in constant 2015 US$) of Algeria in 2009?
Your answer should be very brief. 3.65e+1. What is the difference between the Taxes (in constant 2015 US$) of Afghanistan in 2006 and the Taxes (in constant 2015 US$) of Benin in 2009?
Give a very brief answer. 4.55e+1. What is the difference between the Taxes (in constant 2015 US$) of Afghanistan in 2006 and the Taxes (in constant 2015 US$) of Nepal in 2009?
Make the answer very short. 4.53e+1. What is the difference between the Taxes (in constant 2015 US$) of Algeria in 2006 and the Taxes (in constant 2015 US$) of Benin in 2009?
Provide a short and direct response. 5.94e+09. What is the difference between the Taxes (in constant 2015 US$) in Algeria in 2006 and the Taxes (in constant 2015 US$) in Nepal in 2009?
Provide a short and direct response. 5.74e+09. What is the difference between the Taxes (in constant 2015 US$) of Benin in 2006 and the Taxes (in constant 2015 US$) of Nepal in 2009?
Your answer should be very brief. -4.75e+08. What is the difference between the Taxes (in constant 2015 US$) in Afghanistan in 2006 and the Taxes (in constant 2015 US$) in Algeria in 2010?
Give a very brief answer. 3.63e+1. What is the difference between the Taxes (in constant 2015 US$) of Afghanistan in 2006 and the Taxes (in constant 2015 US$) of Benin in 2010?
Ensure brevity in your answer.  4.55e+1. What is the difference between the Taxes (in constant 2015 US$) in Afghanistan in 2006 and the Taxes (in constant 2015 US$) in Nepal in 2010?
Ensure brevity in your answer.  4.48e+1. What is the difference between the Taxes (in constant 2015 US$) in Algeria in 2006 and the Taxes (in constant 2015 US$) in Benin in 2010?
Your answer should be compact. 5.93e+09. What is the difference between the Taxes (in constant 2015 US$) of Algeria in 2006 and the Taxes (in constant 2015 US$) of Nepal in 2010?
Give a very brief answer. 5.30e+09. What is the difference between the Taxes (in constant 2015 US$) of Benin in 2006 and the Taxes (in constant 2015 US$) of Nepal in 2010?
Keep it short and to the point. -9.18e+08. What is the difference between the Taxes (in constant 2015 US$) in Afghanistan in 2007 and the Taxes (in constant 2015 US$) in Algeria in 2008?
Your answer should be compact. -9.86e+09. What is the difference between the Taxes (in constant 2015 US$) of Afghanistan in 2007 and the Taxes (in constant 2015 US$) of Benin in 2008?
Provide a succinct answer. -5.78e+08. What is the difference between the Taxes (in constant 2015 US$) in Afghanistan in 2007 and the Taxes (in constant 2015 US$) in Nepal in 2008?
Ensure brevity in your answer.  -6.64e+08. What is the difference between the Taxes (in constant 2015 US$) of Algeria in 2007 and the Taxes (in constant 2015 US$) of Benin in 2008?
Your response must be concise. 6.84e+09. What is the difference between the Taxes (in constant 2015 US$) in Algeria in 2007 and the Taxes (in constant 2015 US$) in Nepal in 2008?
Provide a short and direct response. 6.76e+09. What is the difference between the Taxes (in constant 2015 US$) of Benin in 2007 and the Taxes (in constant 2015 US$) of Nepal in 2008?
Offer a terse response. -2.07e+08. What is the difference between the Taxes (in constant 2015 US$) in Afghanistan in 2007 and the Taxes (in constant 2015 US$) in Algeria in 2009?
Keep it short and to the point. -9.59e+09. What is the difference between the Taxes (in constant 2015 US$) in Afghanistan in 2007 and the Taxes (in constant 2015 US$) in Benin in 2009?
Offer a terse response. -5.61e+08. What is the difference between the Taxes (in constant 2015 US$) of Afghanistan in 2007 and the Taxes (in constant 2015 US$) of Nepal in 2009?
Ensure brevity in your answer.  -7.59e+08. What is the difference between the Taxes (in constant 2015 US$) of Algeria in 2007 and the Taxes (in constant 2015 US$) of Benin in 2009?
Your answer should be compact. 6.86e+09. What is the difference between the Taxes (in constant 2015 US$) in Algeria in 2007 and the Taxes (in constant 2015 US$) in Nepal in 2009?
Keep it short and to the point. 6.66e+09. What is the difference between the Taxes (in constant 2015 US$) in Benin in 2007 and the Taxes (in constant 2015 US$) in Nepal in 2009?
Your answer should be very brief. -3.02e+08. What is the difference between the Taxes (in constant 2015 US$) of Afghanistan in 2007 and the Taxes (in constant 2015 US$) of Algeria in 2010?
Provide a short and direct response. -9.79e+09. What is the difference between the Taxes (in constant 2015 US$) of Afghanistan in 2007 and the Taxes (in constant 2015 US$) of Benin in 2010?
Offer a very short reply. -5.70e+08. What is the difference between the Taxes (in constant 2015 US$) in Afghanistan in 2007 and the Taxes (in constant 2015 US$) in Nepal in 2010?
Offer a very short reply. -1.20e+09. What is the difference between the Taxes (in constant 2015 US$) of Algeria in 2007 and the Taxes (in constant 2015 US$) of Benin in 2010?
Ensure brevity in your answer.  6.85e+09. What is the difference between the Taxes (in constant 2015 US$) of Algeria in 2007 and the Taxes (in constant 2015 US$) of Nepal in 2010?
Keep it short and to the point. 6.22e+09. What is the difference between the Taxes (in constant 2015 US$) in Benin in 2007 and the Taxes (in constant 2015 US$) in Nepal in 2010?
Your answer should be very brief. -7.45e+08. What is the difference between the Taxes (in constant 2015 US$) of Afghanistan in 2008 and the Taxes (in constant 2015 US$) of Algeria in 2009?
Provide a short and direct response. -9.57e+09. What is the difference between the Taxes (in constant 2015 US$) in Afghanistan in 2008 and the Taxes (in constant 2015 US$) in Benin in 2009?
Your answer should be very brief. -5.44e+08. What is the difference between the Taxes (in constant 2015 US$) in Afghanistan in 2008 and the Taxes (in constant 2015 US$) in Nepal in 2009?
Provide a succinct answer. -7.43e+08. What is the difference between the Taxes (in constant 2015 US$) in Algeria in 2008 and the Taxes (in constant 2015 US$) in Benin in 2009?
Provide a succinct answer. 9.30e+09. What is the difference between the Taxes (in constant 2015 US$) in Algeria in 2008 and the Taxes (in constant 2015 US$) in Nepal in 2009?
Your response must be concise. 9.10e+09. What is the difference between the Taxes (in constant 2015 US$) in Benin in 2008 and the Taxes (in constant 2015 US$) in Nepal in 2009?
Provide a short and direct response. -1.81e+08. What is the difference between the Taxes (in constant 2015 US$) in Afghanistan in 2008 and the Taxes (in constant 2015 US$) in Algeria in 2010?
Ensure brevity in your answer.  -9.77e+09. What is the difference between the Taxes (in constant 2015 US$) of Afghanistan in 2008 and the Taxes (in constant 2015 US$) of Benin in 2010?
Provide a succinct answer. -5.54e+08. What is the difference between the Taxes (in constant 2015 US$) in Afghanistan in 2008 and the Taxes (in constant 2015 US$) in Nepal in 2010?
Keep it short and to the point. -1.19e+09. What is the difference between the Taxes (in constant 2015 US$) of Algeria in 2008 and the Taxes (in constant 2015 US$) of Benin in 2010?
Provide a succinct answer. 9.29e+09. What is the difference between the Taxes (in constant 2015 US$) of Algeria in 2008 and the Taxes (in constant 2015 US$) of Nepal in 2010?
Offer a terse response. 8.66e+09. What is the difference between the Taxes (in constant 2015 US$) in Benin in 2008 and the Taxes (in constant 2015 US$) in Nepal in 2010?
Provide a short and direct response. -6.24e+08. What is the difference between the Taxes (in constant 2015 US$) of Afghanistan in 2009 and the Taxes (in constant 2015 US$) of Algeria in 2010?
Ensure brevity in your answer.  -9.61e+09. What is the difference between the Taxes (in constant 2015 US$) of Afghanistan in 2009 and the Taxes (in constant 2015 US$) of Benin in 2010?
Your answer should be compact. -3.93e+08. What is the difference between the Taxes (in constant 2015 US$) of Afghanistan in 2009 and the Taxes (in constant 2015 US$) of Nepal in 2010?
Offer a very short reply. -1.02e+09. What is the difference between the Taxes (in constant 2015 US$) in Algeria in 2009 and the Taxes (in constant 2015 US$) in Benin in 2010?
Provide a succinct answer. 9.02e+09. What is the difference between the Taxes (in constant 2015 US$) of Algeria in 2009 and the Taxes (in constant 2015 US$) of Nepal in 2010?
Your response must be concise. 8.39e+09. What is the difference between the Taxes (in constant 2015 US$) of Benin in 2009 and the Taxes (in constant 2015 US$) of Nepal in 2010?
Make the answer very short. -6.41e+08. What is the average Taxes (in constant 2015 US$) in Afghanistan per year?
Your response must be concise. 6.04e+09. What is the average Taxes (in constant 2015 US$) of Algeria per year?
Provide a succinct answer. 7.83e+09. What is the average Taxes (in constant 2015 US$) in Benin per year?
Offer a very short reply. 6.48e+08. What is the average Taxes (in constant 2015 US$) of Nepal per year?
Your answer should be compact. 7.77e+08. In the year 2003, what is the difference between the Taxes (in constant 2015 US$) in Afghanistan and Taxes (in constant 2015 US$) in Algeria?
Ensure brevity in your answer.  -5.10e+09. In the year 2003, what is the difference between the Taxes (in constant 2015 US$) of Afghanistan and Taxes (in constant 2015 US$) of Benin?
Your answer should be compact. -3.16e+08. In the year 2003, what is the difference between the Taxes (in constant 2015 US$) in Afghanistan and Taxes (in constant 2015 US$) in Nepal?
Provide a succinct answer. -3.01e+08. In the year 2003, what is the difference between the Taxes (in constant 2015 US$) in Algeria and Taxes (in constant 2015 US$) in Benin?
Make the answer very short. 4.78e+09. In the year 2003, what is the difference between the Taxes (in constant 2015 US$) in Algeria and Taxes (in constant 2015 US$) in Nepal?
Provide a short and direct response. 4.80e+09. In the year 2003, what is the difference between the Taxes (in constant 2015 US$) in Benin and Taxes (in constant 2015 US$) in Nepal?
Keep it short and to the point. 1.48e+07. In the year 2004, what is the difference between the Taxes (in constant 2015 US$) in Afghanistan and Taxes (in constant 2015 US$) in Algeria?
Offer a terse response. -6.04e+09. In the year 2004, what is the difference between the Taxes (in constant 2015 US$) in Afghanistan and Taxes (in constant 2015 US$) in Benin?
Keep it short and to the point. -3.37e+08. In the year 2004, what is the difference between the Taxes (in constant 2015 US$) in Afghanistan and Taxes (in constant 2015 US$) in Nepal?
Give a very brief answer. -3.35e+08. In the year 2004, what is the difference between the Taxes (in constant 2015 US$) in Algeria and Taxes (in constant 2015 US$) in Benin?
Give a very brief answer. 5.70e+09. In the year 2004, what is the difference between the Taxes (in constant 2015 US$) of Algeria and Taxes (in constant 2015 US$) of Nepal?
Give a very brief answer. 5.70e+09. In the year 2004, what is the difference between the Taxes (in constant 2015 US$) of Benin and Taxes (in constant 2015 US$) of Nepal?
Your answer should be compact. 2.67e+06. In the year 2005, what is the difference between the Taxes (in constant 2015 US$) in Afghanistan and Taxes (in constant 2015 US$) in Algeria?
Offer a very short reply. -6.55e+09. In the year 2005, what is the difference between the Taxes (in constant 2015 US$) of Afghanistan and Taxes (in constant 2015 US$) of Benin?
Offer a very short reply. -3.00e+08. In the year 2005, what is the difference between the Taxes (in constant 2015 US$) in Afghanistan and Taxes (in constant 2015 US$) in Nepal?
Provide a short and direct response. -3.74e+08. In the year 2005, what is the difference between the Taxes (in constant 2015 US$) of Algeria and Taxes (in constant 2015 US$) of Benin?
Offer a very short reply. 6.25e+09. In the year 2005, what is the difference between the Taxes (in constant 2015 US$) in Algeria and Taxes (in constant 2015 US$) in Nepal?
Make the answer very short. 6.18e+09. In the year 2005, what is the difference between the Taxes (in constant 2015 US$) in Benin and Taxes (in constant 2015 US$) in Nepal?
Ensure brevity in your answer.  -7.39e+07. In the year 2006, what is the difference between the Taxes (in constant 2015 US$) of Afghanistan and Taxes (in constant 2015 US$) of Algeria?
Your answer should be compact. 3.95e+1. In the year 2006, what is the difference between the Taxes (in constant 2015 US$) of Afghanistan and Taxes (in constant 2015 US$) of Benin?
Offer a very short reply. 4.58e+1. In the year 2006, what is the difference between the Taxes (in constant 2015 US$) of Afghanistan and Taxes (in constant 2015 US$) of Nepal?
Keep it short and to the point. 4.57e+1. In the year 2006, what is the difference between the Taxes (in constant 2015 US$) of Algeria and Taxes (in constant 2015 US$) of Benin?
Offer a terse response. 6.22e+09. In the year 2006, what is the difference between the Taxes (in constant 2015 US$) in Algeria and Taxes (in constant 2015 US$) in Nepal?
Provide a succinct answer. 6.17e+09. In the year 2006, what is the difference between the Taxes (in constant 2015 US$) in Benin and Taxes (in constant 2015 US$) in Nepal?
Your answer should be very brief. -4.46e+07. In the year 2007, what is the difference between the Taxes (in constant 2015 US$) of Afghanistan and Taxes (in constant 2015 US$) of Algeria?
Provide a short and direct response. -7.42e+09. In the year 2007, what is the difference between the Taxes (in constant 2015 US$) in Afghanistan and Taxes (in constant 2015 US$) in Benin?
Give a very brief answer. -4.57e+08. In the year 2007, what is the difference between the Taxes (in constant 2015 US$) of Afghanistan and Taxes (in constant 2015 US$) of Nepal?
Offer a terse response. -4.72e+08. In the year 2007, what is the difference between the Taxes (in constant 2015 US$) of Algeria and Taxes (in constant 2015 US$) of Benin?
Provide a short and direct response. 6.96e+09. In the year 2007, what is the difference between the Taxes (in constant 2015 US$) of Algeria and Taxes (in constant 2015 US$) of Nepal?
Ensure brevity in your answer.  6.95e+09. In the year 2007, what is the difference between the Taxes (in constant 2015 US$) of Benin and Taxes (in constant 2015 US$) of Nepal?
Your response must be concise. -1.51e+07. In the year 2008, what is the difference between the Taxes (in constant 2015 US$) of Afghanistan and Taxes (in constant 2015 US$) of Algeria?
Keep it short and to the point. -9.84e+09. In the year 2008, what is the difference between the Taxes (in constant 2015 US$) of Afghanistan and Taxes (in constant 2015 US$) of Benin?
Make the answer very short. -5.62e+08. In the year 2008, what is the difference between the Taxes (in constant 2015 US$) in Afghanistan and Taxes (in constant 2015 US$) in Nepal?
Provide a succinct answer. -6.48e+08. In the year 2008, what is the difference between the Taxes (in constant 2015 US$) of Algeria and Taxes (in constant 2015 US$) of Benin?
Offer a terse response. 9.28e+09. In the year 2008, what is the difference between the Taxes (in constant 2015 US$) of Algeria and Taxes (in constant 2015 US$) of Nepal?
Ensure brevity in your answer.  9.20e+09. In the year 2008, what is the difference between the Taxes (in constant 2015 US$) of Benin and Taxes (in constant 2015 US$) of Nepal?
Make the answer very short. -8.62e+07. In the year 2009, what is the difference between the Taxes (in constant 2015 US$) in Afghanistan and Taxes (in constant 2015 US$) in Algeria?
Your response must be concise. -9.41e+09. In the year 2009, what is the difference between the Taxes (in constant 2015 US$) in Afghanistan and Taxes (in constant 2015 US$) in Benin?
Keep it short and to the point. -3.84e+08. In the year 2009, what is the difference between the Taxes (in constant 2015 US$) of Afghanistan and Taxes (in constant 2015 US$) of Nepal?
Offer a very short reply. -5.82e+08. In the year 2009, what is the difference between the Taxes (in constant 2015 US$) of Algeria and Taxes (in constant 2015 US$) of Benin?
Your response must be concise. 9.03e+09. In the year 2009, what is the difference between the Taxes (in constant 2015 US$) of Algeria and Taxes (in constant 2015 US$) of Nepal?
Your response must be concise. 8.83e+09. In the year 2009, what is the difference between the Taxes (in constant 2015 US$) in Benin and Taxes (in constant 2015 US$) in Nepal?
Your response must be concise. -1.99e+08. In the year 2010, what is the difference between the Taxes (in constant 2015 US$) in Afghanistan and Taxes (in constant 2015 US$) in Algeria?
Your answer should be very brief. -9.46e+09. In the year 2010, what is the difference between the Taxes (in constant 2015 US$) in Afghanistan and Taxes (in constant 2015 US$) in Benin?
Your answer should be very brief. -2.39e+08. In the year 2010, what is the difference between the Taxes (in constant 2015 US$) in Afghanistan and Taxes (in constant 2015 US$) in Nepal?
Your response must be concise. -8.71e+08. In the year 2010, what is the difference between the Taxes (in constant 2015 US$) of Algeria and Taxes (in constant 2015 US$) of Benin?
Offer a terse response. 9.22e+09. In the year 2010, what is the difference between the Taxes (in constant 2015 US$) of Algeria and Taxes (in constant 2015 US$) of Nepal?
Make the answer very short. 8.58e+09. In the year 2010, what is the difference between the Taxes (in constant 2015 US$) of Benin and Taxes (in constant 2015 US$) of Nepal?
Your answer should be compact. -6.32e+08. What is the ratio of the Taxes (in constant 2015 US$) in Afghanistan in 2003 to that in 2004?
Make the answer very short. 0.71. What is the ratio of the Taxes (in constant 2015 US$) in Algeria in 2003 to that in 2004?
Keep it short and to the point. 0.84. What is the ratio of the Taxes (in constant 2015 US$) in Benin in 2003 to that in 2004?
Offer a very short reply. 0.87. What is the ratio of the Taxes (in constant 2015 US$) in Nepal in 2003 to that in 2004?
Make the answer very short. 0.84. What is the ratio of the Taxes (in constant 2015 US$) in Afghanistan in 2003 to that in 2005?
Your response must be concise. 0.58. What is the ratio of the Taxes (in constant 2015 US$) of Algeria in 2003 to that in 2005?
Offer a terse response. 0.77. What is the ratio of the Taxes (in constant 2015 US$) of Benin in 2003 to that in 2005?
Ensure brevity in your answer.  0.87. What is the ratio of the Taxes (in constant 2015 US$) in Nepal in 2003 to that in 2005?
Provide a succinct answer. 0.73. What is the ratio of the Taxes (in constant 2015 US$) of Afghanistan in 2003 to that in 2006?
Offer a terse response. 0. What is the ratio of the Taxes (in constant 2015 US$) in Algeria in 2003 to that in 2006?
Provide a short and direct response. 0.77. What is the ratio of the Taxes (in constant 2015 US$) of Benin in 2003 to that in 2006?
Offer a terse response. 0.77. What is the ratio of the Taxes (in constant 2015 US$) in Nepal in 2003 to that in 2006?
Keep it short and to the point. 0.69. What is the ratio of the Taxes (in constant 2015 US$) of Afghanistan in 2003 to that in 2007?
Your answer should be very brief. 0.41. What is the ratio of the Taxes (in constant 2015 US$) in Algeria in 2003 to that in 2007?
Keep it short and to the point. 0.68. What is the ratio of the Taxes (in constant 2015 US$) in Benin in 2003 to that in 2007?
Provide a succinct answer. 0.59. What is the ratio of the Taxes (in constant 2015 US$) of Nepal in 2003 to that in 2007?
Your response must be concise. 0.56. What is the ratio of the Taxes (in constant 2015 US$) of Afghanistan in 2003 to that in 2008?
Provide a succinct answer. 0.39. What is the ratio of the Taxes (in constant 2015 US$) in Algeria in 2003 to that in 2008?
Your answer should be very brief. 0.51. What is the ratio of the Taxes (in constant 2015 US$) in Benin in 2003 to that in 2008?
Offer a terse response. 0.5. What is the ratio of the Taxes (in constant 2015 US$) of Nepal in 2003 to that in 2008?
Make the answer very short. 0.44. What is the ratio of the Taxes (in constant 2015 US$) in Afghanistan in 2003 to that in 2009?
Make the answer very short. 0.25. What is the ratio of the Taxes (in constant 2015 US$) of Algeria in 2003 to that in 2009?
Your response must be concise. 0.53. What is the ratio of the Taxes (in constant 2015 US$) in Benin in 2003 to that in 2009?
Provide a short and direct response. 0.51. What is the ratio of the Taxes (in constant 2015 US$) in Nepal in 2003 to that in 2009?
Offer a very short reply. 0.4. What is the ratio of the Taxes (in constant 2015 US$) of Afghanistan in 2003 to that in 2010?
Provide a short and direct response. 0.18. What is the ratio of the Taxes (in constant 2015 US$) in Algeria in 2003 to that in 2010?
Provide a short and direct response. 0.52. What is the ratio of the Taxes (in constant 2015 US$) in Benin in 2003 to that in 2010?
Offer a very short reply. 0.51. What is the ratio of the Taxes (in constant 2015 US$) in Nepal in 2003 to that in 2010?
Give a very brief answer. 0.28. What is the ratio of the Taxes (in constant 2015 US$) of Afghanistan in 2004 to that in 2005?
Provide a short and direct response. 0.81. What is the ratio of the Taxes (in constant 2015 US$) of Algeria in 2004 to that in 2005?
Give a very brief answer. 0.92. What is the ratio of the Taxes (in constant 2015 US$) in Benin in 2004 to that in 2005?
Offer a very short reply. 1. What is the ratio of the Taxes (in constant 2015 US$) in Nepal in 2004 to that in 2005?
Keep it short and to the point. 0.87. What is the ratio of the Taxes (in constant 2015 US$) in Afghanistan in 2004 to that in 2006?
Provide a short and direct response. 0. What is the ratio of the Taxes (in constant 2015 US$) of Algeria in 2004 to that in 2006?
Offer a terse response. 0.92. What is the ratio of the Taxes (in constant 2015 US$) of Benin in 2004 to that in 2006?
Keep it short and to the point. 0.89. What is the ratio of the Taxes (in constant 2015 US$) in Nepal in 2004 to that in 2006?
Your answer should be compact. 0.82. What is the ratio of the Taxes (in constant 2015 US$) in Afghanistan in 2004 to that in 2007?
Give a very brief answer. 0.58. What is the ratio of the Taxes (in constant 2015 US$) of Algeria in 2004 to that in 2007?
Ensure brevity in your answer.  0.81. What is the ratio of the Taxes (in constant 2015 US$) of Benin in 2004 to that in 2007?
Provide a short and direct response. 0.68. What is the ratio of the Taxes (in constant 2015 US$) in Nepal in 2004 to that in 2007?
Give a very brief answer. 0.66. What is the ratio of the Taxes (in constant 2015 US$) of Afghanistan in 2004 to that in 2008?
Make the answer very short. 0.55. What is the ratio of the Taxes (in constant 2015 US$) of Algeria in 2004 to that in 2008?
Your response must be concise. 0.61. What is the ratio of the Taxes (in constant 2015 US$) in Benin in 2004 to that in 2008?
Keep it short and to the point. 0.58. What is the ratio of the Taxes (in constant 2015 US$) of Nepal in 2004 to that in 2008?
Your answer should be compact. 0.53. What is the ratio of the Taxes (in constant 2015 US$) in Afghanistan in 2004 to that in 2009?
Offer a terse response. 0.35. What is the ratio of the Taxes (in constant 2015 US$) in Algeria in 2004 to that in 2009?
Provide a short and direct response. 0.63. What is the ratio of the Taxes (in constant 2015 US$) in Benin in 2004 to that in 2009?
Give a very brief answer. 0.59. What is the ratio of the Taxes (in constant 2015 US$) in Nepal in 2004 to that in 2009?
Your answer should be very brief. 0.48. What is the ratio of the Taxes (in constant 2015 US$) in Afghanistan in 2004 to that in 2010?
Provide a short and direct response. 0.26. What is the ratio of the Taxes (in constant 2015 US$) of Algeria in 2004 to that in 2010?
Give a very brief answer. 0.62. What is the ratio of the Taxes (in constant 2015 US$) in Benin in 2004 to that in 2010?
Offer a very short reply. 0.59. What is the ratio of the Taxes (in constant 2015 US$) of Nepal in 2004 to that in 2010?
Your answer should be very brief. 0.33. What is the ratio of the Taxes (in constant 2015 US$) in Afghanistan in 2005 to that in 2006?
Keep it short and to the point. 0. What is the ratio of the Taxes (in constant 2015 US$) of Algeria in 2005 to that in 2006?
Ensure brevity in your answer.  1. What is the ratio of the Taxes (in constant 2015 US$) of Benin in 2005 to that in 2006?
Your answer should be very brief. 0.89. What is the ratio of the Taxes (in constant 2015 US$) in Nepal in 2005 to that in 2006?
Your response must be concise. 0.95. What is the ratio of the Taxes (in constant 2015 US$) in Afghanistan in 2005 to that in 2007?
Offer a terse response. 0.72. What is the ratio of the Taxes (in constant 2015 US$) in Algeria in 2005 to that in 2007?
Give a very brief answer. 0.88. What is the ratio of the Taxes (in constant 2015 US$) in Benin in 2005 to that in 2007?
Offer a very short reply. 0.68. What is the ratio of the Taxes (in constant 2015 US$) in Nepal in 2005 to that in 2007?
Your response must be concise. 0.77. What is the ratio of the Taxes (in constant 2015 US$) in Afghanistan in 2005 to that in 2008?
Keep it short and to the point. 0.68. What is the ratio of the Taxes (in constant 2015 US$) of Algeria in 2005 to that in 2008?
Provide a short and direct response. 0.67. What is the ratio of the Taxes (in constant 2015 US$) in Benin in 2005 to that in 2008?
Provide a short and direct response. 0.58. What is the ratio of the Taxes (in constant 2015 US$) in Nepal in 2005 to that in 2008?
Ensure brevity in your answer.  0.61. What is the ratio of the Taxes (in constant 2015 US$) in Afghanistan in 2005 to that in 2009?
Your answer should be very brief. 0.43. What is the ratio of the Taxes (in constant 2015 US$) in Algeria in 2005 to that in 2009?
Your answer should be very brief. 0.68. What is the ratio of the Taxes (in constant 2015 US$) in Benin in 2005 to that in 2009?
Your response must be concise. 0.59. What is the ratio of the Taxes (in constant 2015 US$) in Nepal in 2005 to that in 2009?
Provide a short and direct response. 0.55. What is the ratio of the Taxes (in constant 2015 US$) of Afghanistan in 2005 to that in 2010?
Your answer should be very brief. 0.32. What is the ratio of the Taxes (in constant 2015 US$) of Algeria in 2005 to that in 2010?
Offer a very short reply. 0.67. What is the ratio of the Taxes (in constant 2015 US$) of Benin in 2005 to that in 2010?
Your answer should be compact. 0.59. What is the ratio of the Taxes (in constant 2015 US$) in Nepal in 2005 to that in 2010?
Your response must be concise. 0.38. What is the ratio of the Taxes (in constant 2015 US$) of Afghanistan in 2006 to that in 2007?
Your answer should be compact. 174.85. What is the ratio of the Taxes (in constant 2015 US$) in Algeria in 2006 to that in 2007?
Give a very brief answer. 0.88. What is the ratio of the Taxes (in constant 2015 US$) in Benin in 2006 to that in 2007?
Offer a very short reply. 0.76. What is the ratio of the Taxes (in constant 2015 US$) of Nepal in 2006 to that in 2007?
Your answer should be compact. 0.81. What is the ratio of the Taxes (in constant 2015 US$) of Afghanistan in 2006 to that in 2008?
Provide a succinct answer. 164.63. What is the ratio of the Taxes (in constant 2015 US$) in Algeria in 2006 to that in 2008?
Your response must be concise. 0.67. What is the ratio of the Taxes (in constant 2015 US$) of Benin in 2006 to that in 2008?
Your answer should be very brief. 0.65. What is the ratio of the Taxes (in constant 2015 US$) of Nepal in 2006 to that in 2008?
Your answer should be very brief. 0.64. What is the ratio of the Taxes (in constant 2015 US$) in Afghanistan in 2006 to that in 2009?
Make the answer very short. 104.72. What is the ratio of the Taxes (in constant 2015 US$) in Algeria in 2006 to that in 2009?
Offer a very short reply. 0.69. What is the ratio of the Taxes (in constant 2015 US$) of Benin in 2006 to that in 2009?
Provide a succinct answer. 0.67. What is the ratio of the Taxes (in constant 2015 US$) in Nepal in 2006 to that in 2009?
Provide a short and direct response. 0.58. What is the ratio of the Taxes (in constant 2015 US$) in Afghanistan in 2006 to that in 2010?
Keep it short and to the point. 77.69. What is the ratio of the Taxes (in constant 2015 US$) in Algeria in 2006 to that in 2010?
Provide a succinct answer. 0.67. What is the ratio of the Taxes (in constant 2015 US$) of Benin in 2006 to that in 2010?
Keep it short and to the point. 0.66. What is the ratio of the Taxes (in constant 2015 US$) in Nepal in 2006 to that in 2010?
Make the answer very short. 0.4. What is the ratio of the Taxes (in constant 2015 US$) in Afghanistan in 2007 to that in 2008?
Provide a succinct answer. 0.94. What is the ratio of the Taxes (in constant 2015 US$) in Algeria in 2007 to that in 2008?
Give a very brief answer. 0.76. What is the ratio of the Taxes (in constant 2015 US$) of Benin in 2007 to that in 2008?
Your answer should be compact. 0.86. What is the ratio of the Taxes (in constant 2015 US$) in Nepal in 2007 to that in 2008?
Your answer should be compact. 0.79. What is the ratio of the Taxes (in constant 2015 US$) of Afghanistan in 2007 to that in 2009?
Offer a terse response. 0.6. What is the ratio of the Taxes (in constant 2015 US$) of Algeria in 2007 to that in 2009?
Keep it short and to the point. 0.78. What is the ratio of the Taxes (in constant 2015 US$) of Benin in 2007 to that in 2009?
Offer a very short reply. 0.87. What is the ratio of the Taxes (in constant 2015 US$) in Nepal in 2007 to that in 2009?
Provide a short and direct response. 0.72. What is the ratio of the Taxes (in constant 2015 US$) of Afghanistan in 2007 to that in 2010?
Offer a terse response. 0.44. What is the ratio of the Taxes (in constant 2015 US$) of Algeria in 2007 to that in 2010?
Your response must be concise. 0.76. What is the ratio of the Taxes (in constant 2015 US$) in Benin in 2007 to that in 2010?
Your answer should be very brief. 0.86. What is the ratio of the Taxes (in constant 2015 US$) in Nepal in 2007 to that in 2010?
Your answer should be very brief. 0.5. What is the ratio of the Taxes (in constant 2015 US$) in Afghanistan in 2008 to that in 2009?
Make the answer very short. 0.64. What is the ratio of the Taxes (in constant 2015 US$) of Algeria in 2008 to that in 2009?
Provide a short and direct response. 1.03. What is the ratio of the Taxes (in constant 2015 US$) in Benin in 2008 to that in 2009?
Keep it short and to the point. 1.02. What is the ratio of the Taxes (in constant 2015 US$) in Nepal in 2008 to that in 2009?
Provide a short and direct response. 0.91. What is the ratio of the Taxes (in constant 2015 US$) in Afghanistan in 2008 to that in 2010?
Offer a terse response. 0.47. What is the ratio of the Taxes (in constant 2015 US$) of Algeria in 2008 to that in 2010?
Provide a succinct answer. 1.01. What is the ratio of the Taxes (in constant 2015 US$) of Nepal in 2008 to that in 2010?
Provide a short and direct response. 0.63. What is the ratio of the Taxes (in constant 2015 US$) of Afghanistan in 2009 to that in 2010?
Your answer should be very brief. 0.74. What is the ratio of the Taxes (in constant 2015 US$) of Algeria in 2009 to that in 2010?
Provide a short and direct response. 0.98. What is the ratio of the Taxes (in constant 2015 US$) in Nepal in 2009 to that in 2010?
Give a very brief answer. 0.7. What is the difference between the highest and the second highest Taxes (in constant 2015 US$) in Afghanistan?
Ensure brevity in your answer.  4.57e+1. What is the difference between the highest and the second highest Taxes (in constant 2015 US$) in Algeria?
Offer a terse response. 7.40e+07. What is the difference between the highest and the second highest Taxes (in constant 2015 US$) of Benin?
Provide a succinct answer. 7.49e+06. What is the difference between the highest and the second highest Taxes (in constant 2015 US$) in Nepal?
Your response must be concise. 4.43e+08. What is the difference between the highest and the lowest Taxes (in constant 2015 US$) in Afghanistan?
Provide a succinct answer. 4.62e+1. What is the difference between the highest and the lowest Taxes (in constant 2015 US$) of Algeria?
Your response must be concise. 4.92e+09. What is the difference between the highest and the lowest Taxes (in constant 2015 US$) of Benin?
Offer a very short reply. 4.18e+08. What is the difference between the highest and the lowest Taxes (in constant 2015 US$) in Nepal?
Ensure brevity in your answer.  1.06e+09. 